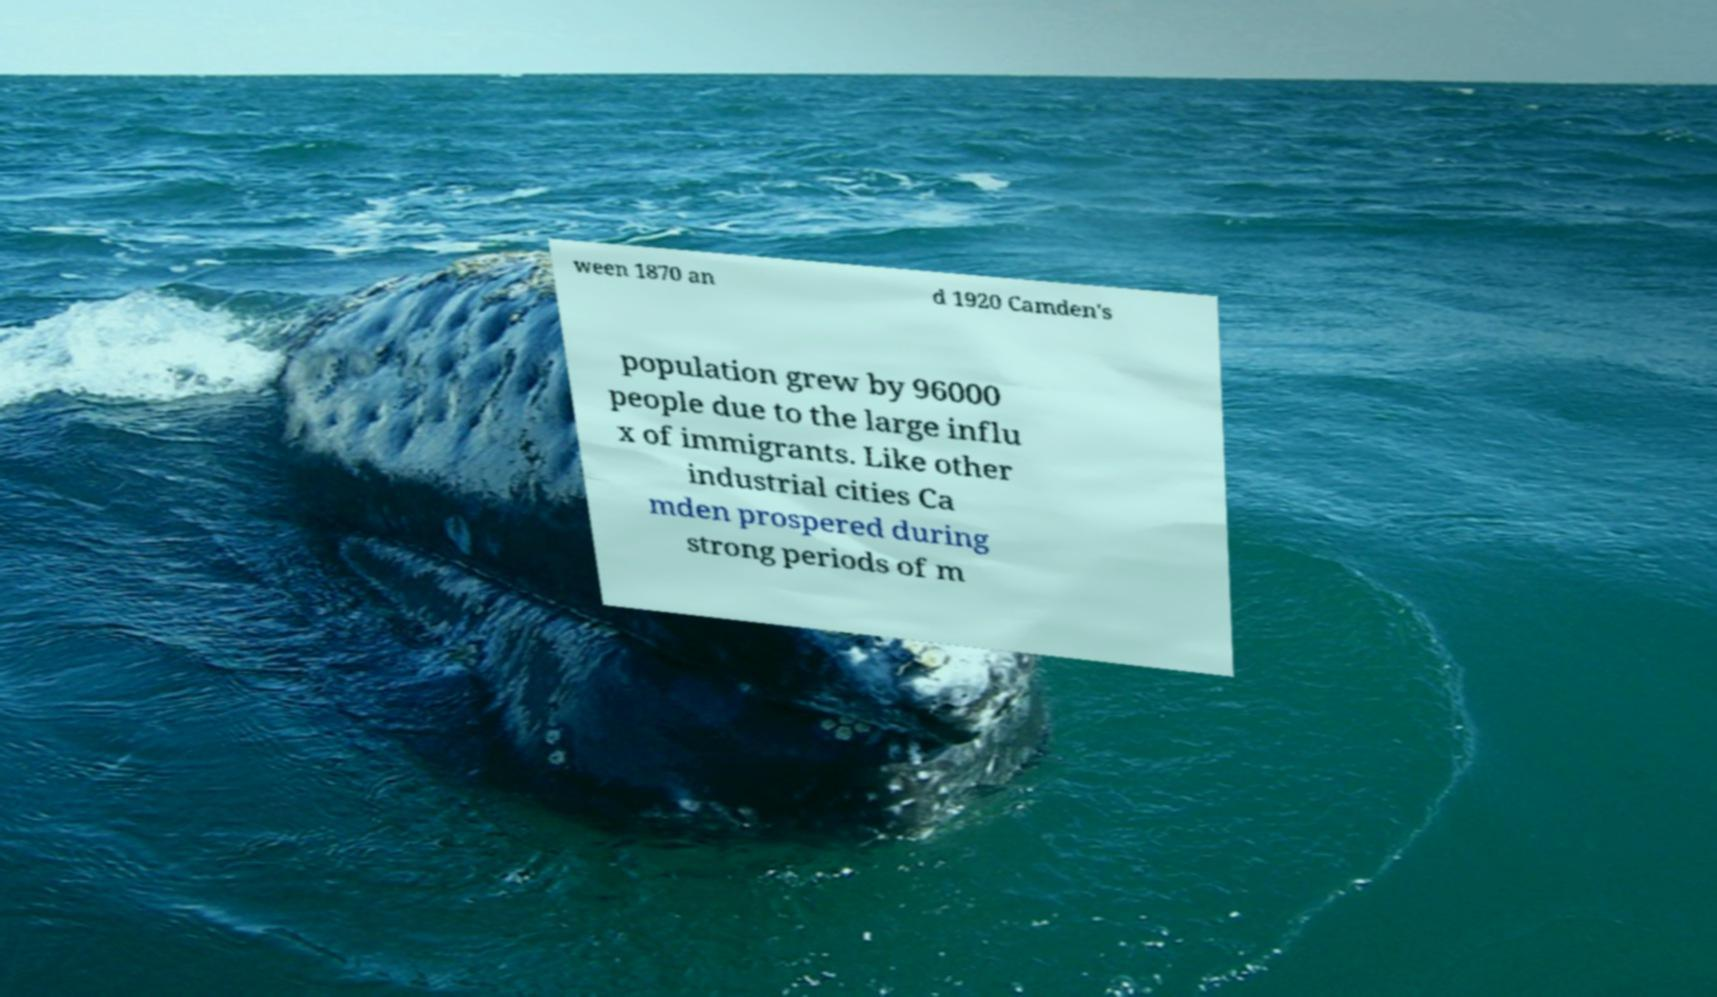Please read and relay the text visible in this image. What does it say? ween 1870 an d 1920 Camden's population grew by 96000 people due to the large influ x of immigrants. Like other industrial cities Ca mden prospered during strong periods of m 